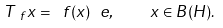<formula> <loc_0><loc_0><loc_500><loc_500>T _ { \ f } x = \ f ( x ) \ e , \quad x \in B ( H ) .</formula> 